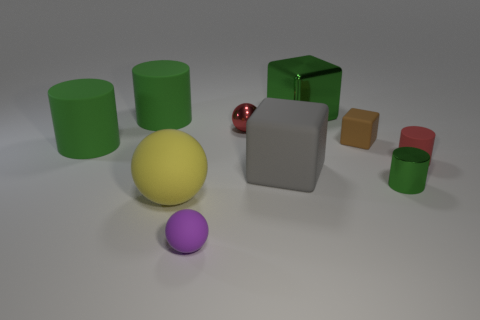Are there any cyan shiny things that have the same size as the green metal cylinder?
Your answer should be compact. No. There is a tiny sphere that is in front of the gray matte thing; what is its material?
Your answer should be compact. Rubber. There is a tiny sphere that is made of the same material as the gray block; what color is it?
Provide a short and direct response. Purple. How many metallic things are cylinders or red spheres?
Offer a terse response. 2. The gray matte object that is the same size as the green block is what shape?
Keep it short and to the point. Cube. What number of things are either metal things on the left side of the green metal cylinder or large rubber objects that are in front of the small red ball?
Provide a succinct answer. 5. There is another red thing that is the same size as the red matte thing; what is its material?
Your answer should be very brief. Metal. How many other things are there of the same material as the purple object?
Offer a very short reply. 6. Are there the same number of tiny purple things in front of the small red matte cylinder and yellow matte spheres that are right of the big yellow matte sphere?
Give a very brief answer. No. What number of purple objects are either cylinders or matte spheres?
Your response must be concise. 1. 